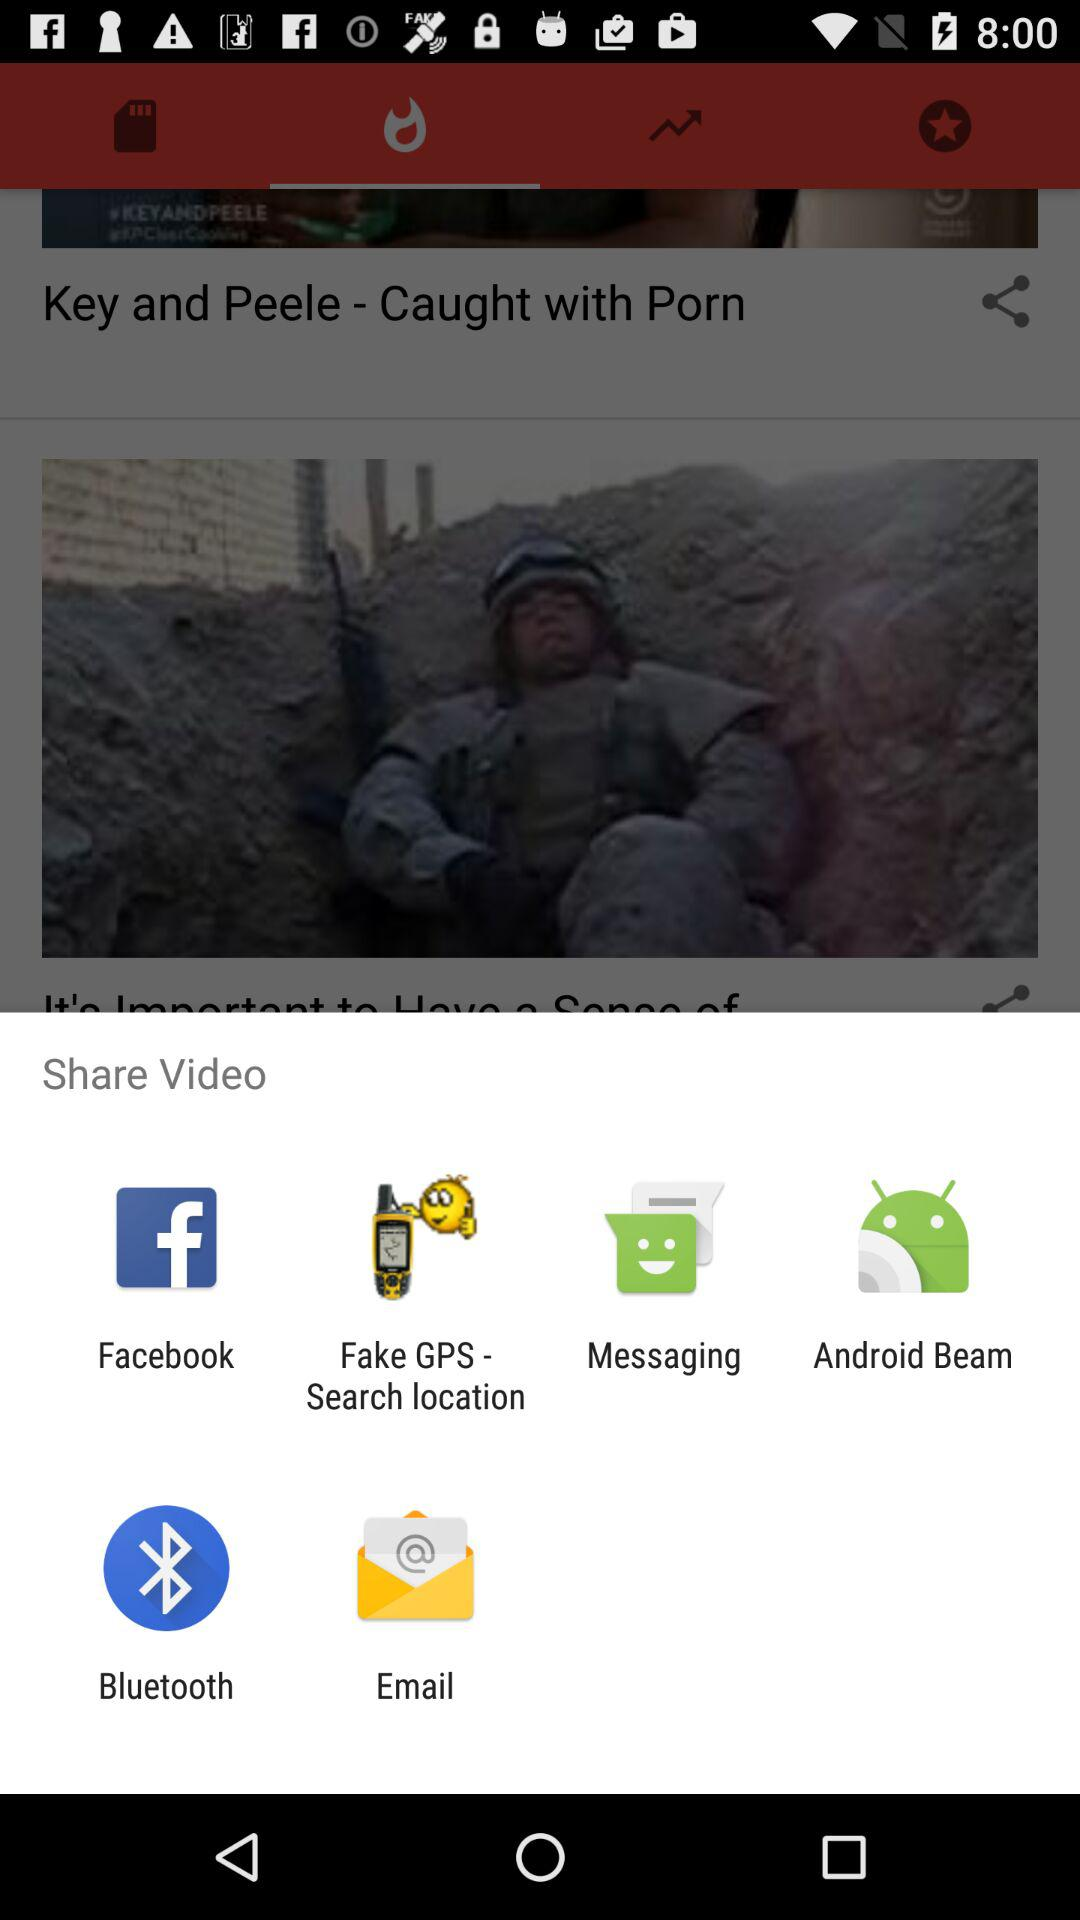What are the options to share the video? The options are "Facebook", "Fake GPS - Search location", "Messaging", "Android Beam", "Bluetooth" and "Email". 